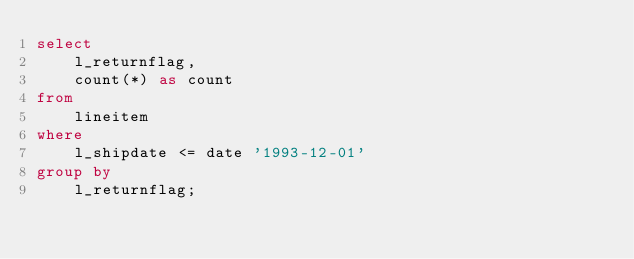Convert code to text. <code><loc_0><loc_0><loc_500><loc_500><_SQL_>select
	l_returnflag,
	count(*) as count
from
	lineitem
where
	l_shipdate <= date '1993-12-01'
group by
	l_returnflag;</code> 